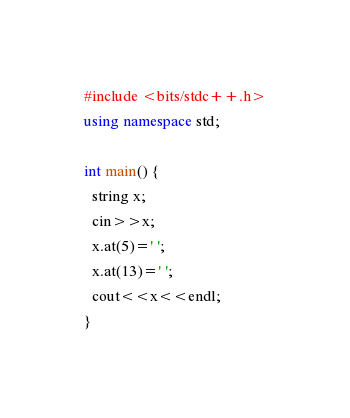<code> <loc_0><loc_0><loc_500><loc_500><_C++_>#include <bits/stdc++.h>
using namespace std;
  
int main() {
  string x;
  cin>>x;
  x.at(5)=' ';
  x.at(13)=' ';
  cout<<x<<endl;
}</code> 